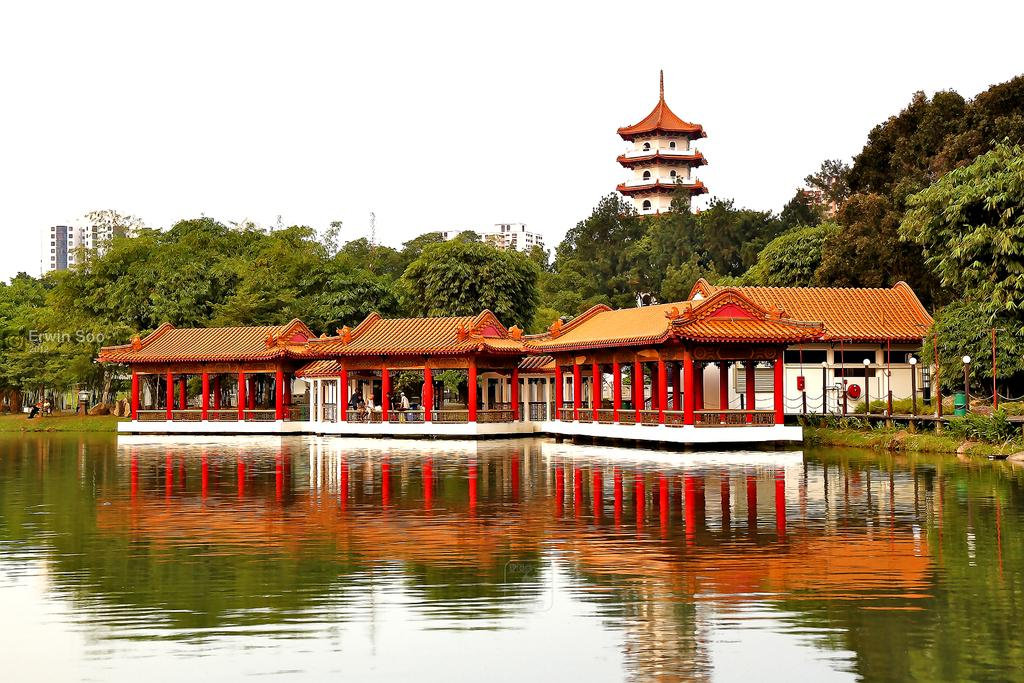What structures are built on the water in the image? There are three shelters built on the water in the image. What can be seen in the background of the image? There are trees and buildings in the background of the image. What is visible in the sky in the image? There are clouds in the sky in the image. What thought is the top of the building having in the image? There is no indication of any thoughts or emotions associated with the buildings in the image. 